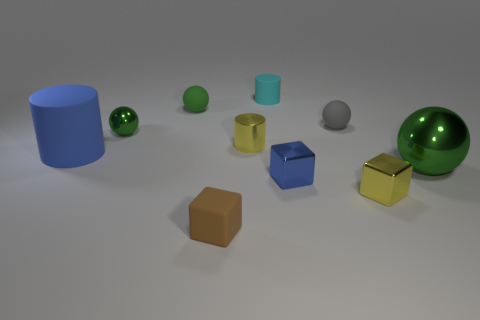Are there any small rubber objects that are in front of the green ball that is behind the green metallic ball that is to the left of the big green thing? Yes, there appears to be a small rubber object situated in front of the matte green ball, which is positioned behind the green metallic ball, to the left of the largest green cylindrical object in the image. 